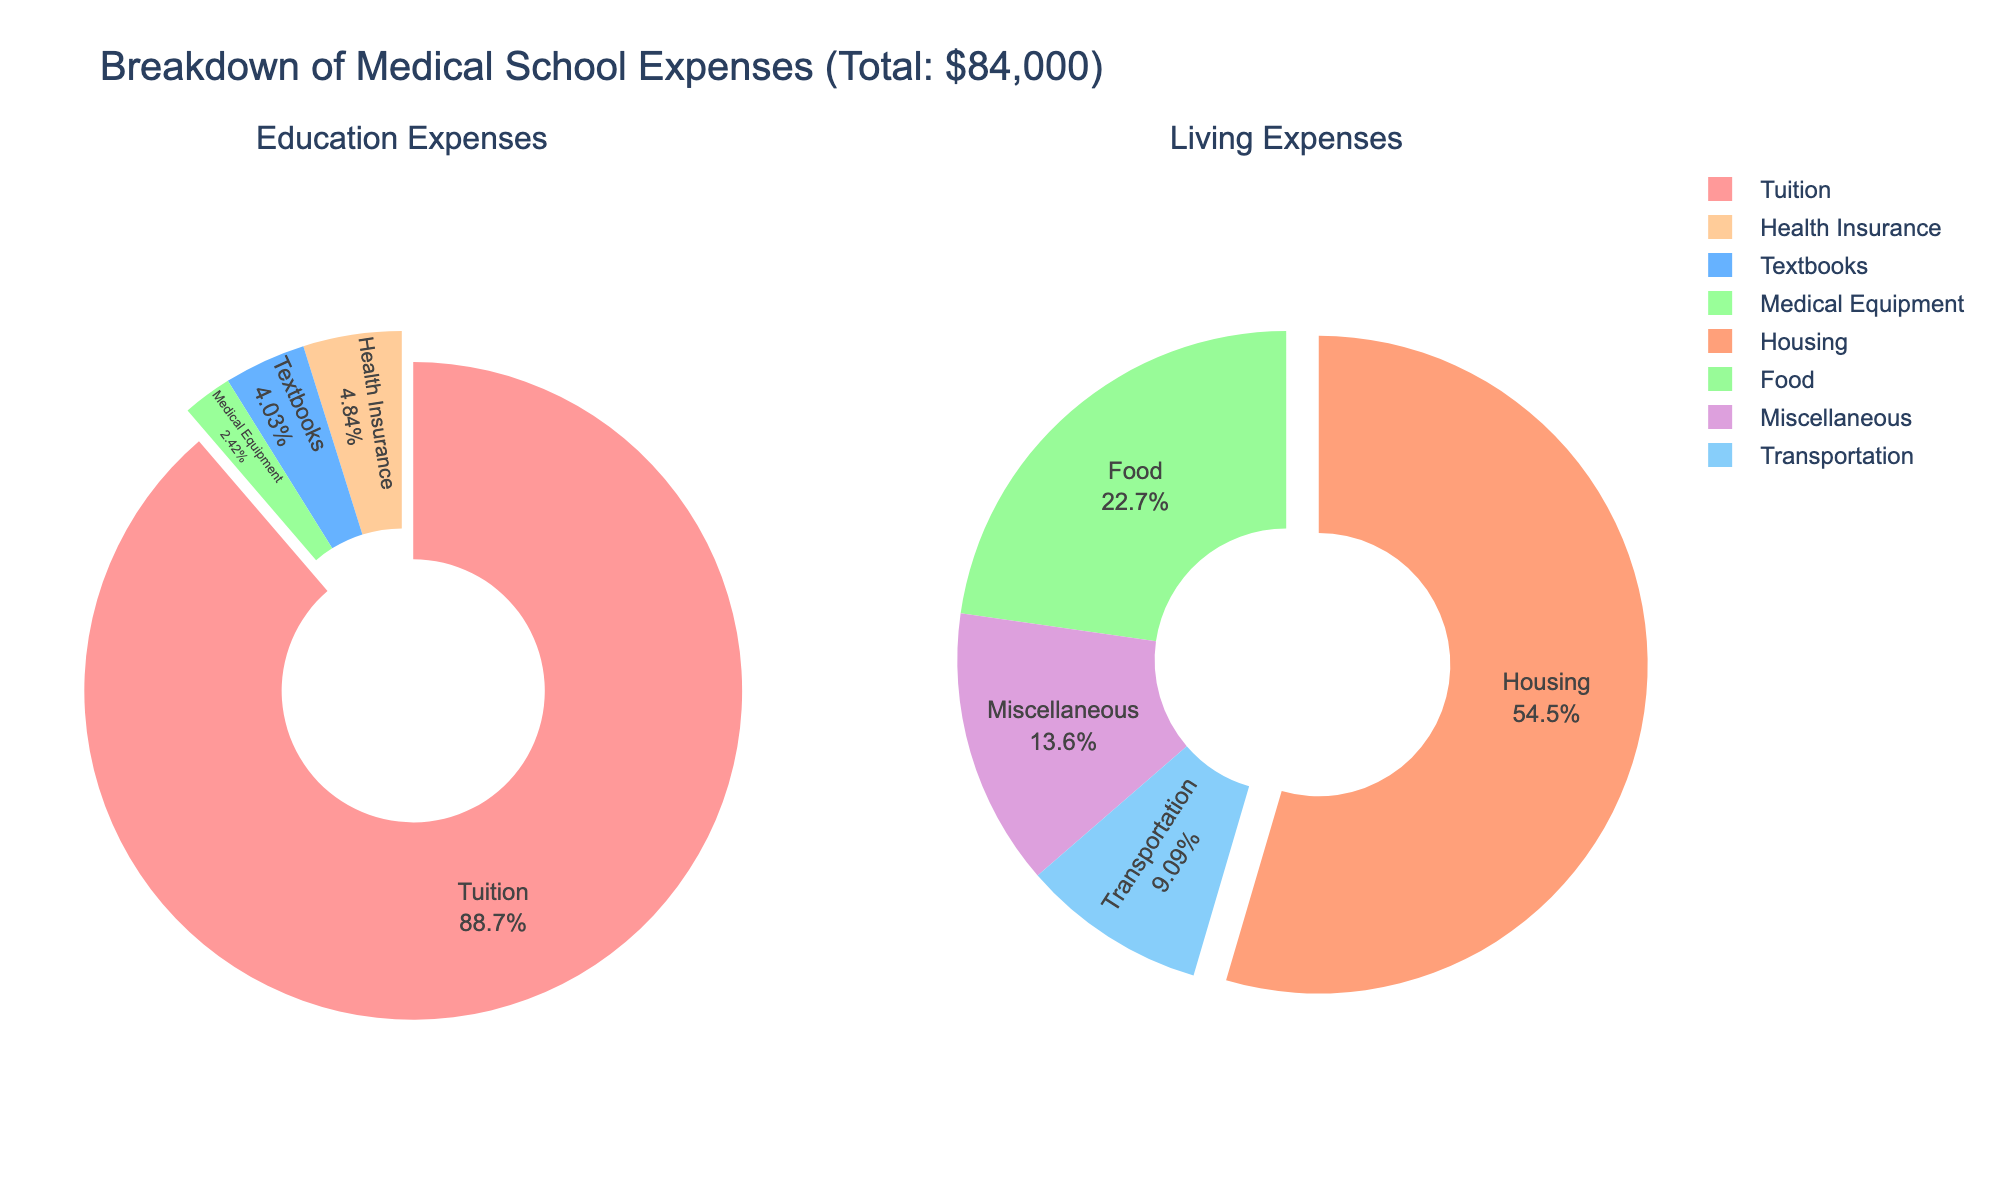What percentage of research methodologies in Biology is Experimental? By looking at the pie chart for Biology, you can see the sector labeled as Experimental, which shows the percentage.
Answer: 45% Which discipline relies most heavily on Experimental methodology? By comparing the size of the Experimental methodology sectors in each pie chart for all disciplines, you can identify that Chemistry has the largest Experimental sector.
Answer: Chemistry What percentage of methodologies in Psychology is Qualitative? Refer to the pie chart for Psychology, look for the sector labeled Qualitative to find the percentage.
Answer: 20% Is theoretical methodology used in Chemistry? Examine the pie chart for Chemistry. There are no sectors labeled as Theoretical, implying this methodology is not used in Chemistry.
Answer: No What are the top two methodologies used in Sociology by their percentages? Look at the Sociology pie chart and identify the two largest sectors which are Qualitative and Survey.
Answer: Qualitative, Survey Which discipline has the most balance across different methodologies? Find the discipline where the pie chart sectors are most similar in size, indicating a more balanced use of methodologies. Biologically, this looks more balanced compared to others.
Answer: Biology Which discipline uses Meta-analysis least? Look at the sectors labeled Meta-analysis in each pie chart. Physics has no Meta-analysis sector, making it the least.
Answer: Physics Compare the use of Computational methodologies in Physics and Chemistry. Which uses it more? Compare the sizes or percentages of the Computational sectors in both Physics and Chemistry charts specifically. Chemistry uses Computational methodology less than Physics.
Answer: Physics What's the combined percentage of Observational methodology used across Biology and Physics? Add the percentages of Observational in both Biology and Physics pie charts: 25% (Biology) + 5% (Physics).
Answer: 30% Which methodology is common to both Sociology and Psychology, and what are their respective percentages? Identify shared methodologies between the pie charts of Sociology and Psychology, focusing on Qualitative, then observe and note their respective percentages.
Answer: Qualitative, 40% (Sociology), 20% (Psychology) 